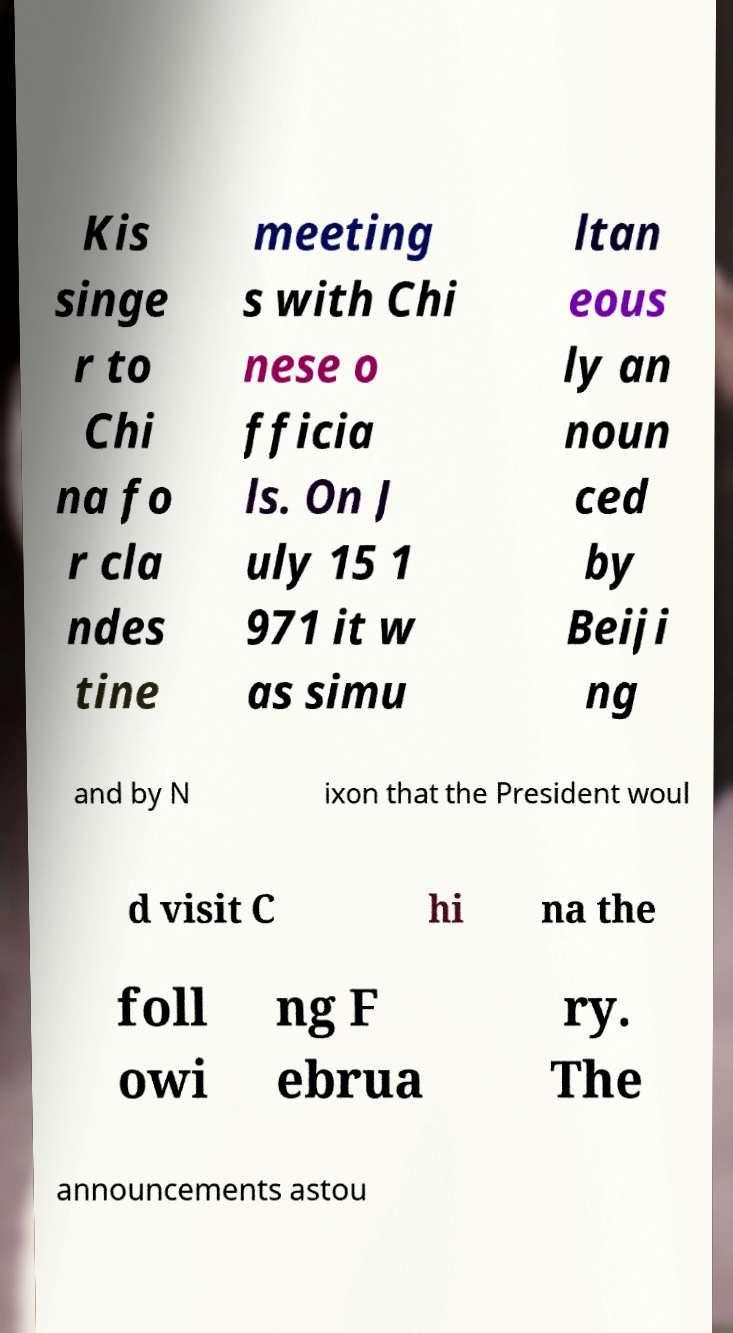There's text embedded in this image that I need extracted. Can you transcribe it verbatim? Kis singe r to Chi na fo r cla ndes tine meeting s with Chi nese o fficia ls. On J uly 15 1 971 it w as simu ltan eous ly an noun ced by Beiji ng and by N ixon that the President woul d visit C hi na the foll owi ng F ebrua ry. The announcements astou 